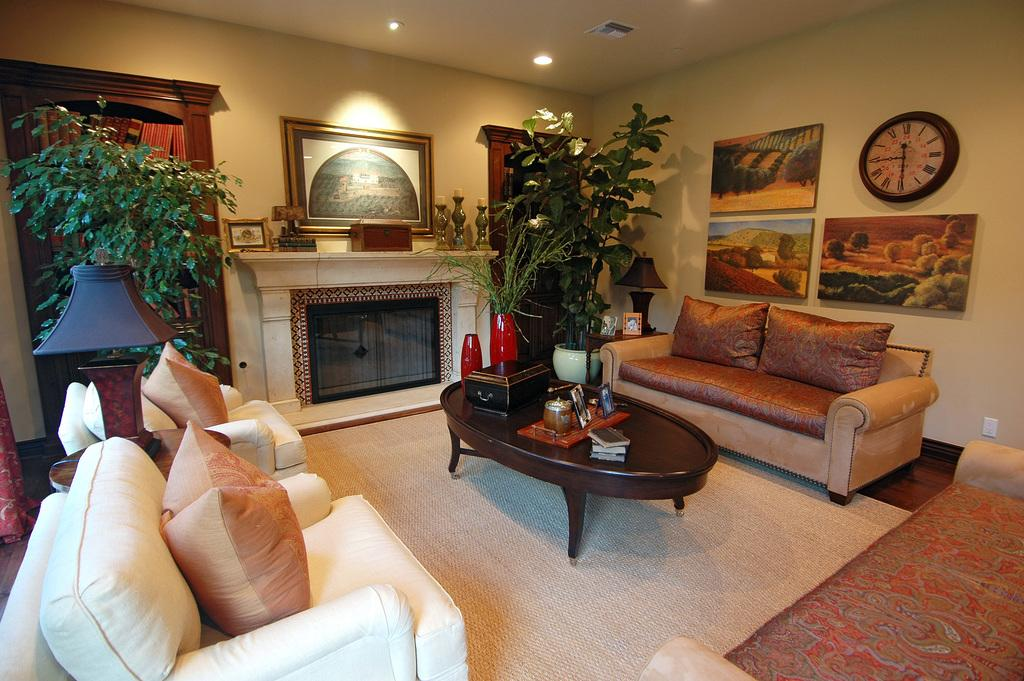What type of furniture is present in the room? There are sofas in the room. What other objects can be found in the room? There are plants, lights, wall paintings, and a wall clock in the room. Can you describe the decorative elements in the room? The room features wall paintings and a wall clock. What might provide illumination in the room? There are lights in the room. How does the sheet of paper interact with the friction in the room? There is no sheet of paper present in the image, so it is not possible to determine how it would interact with the friction in the room. 